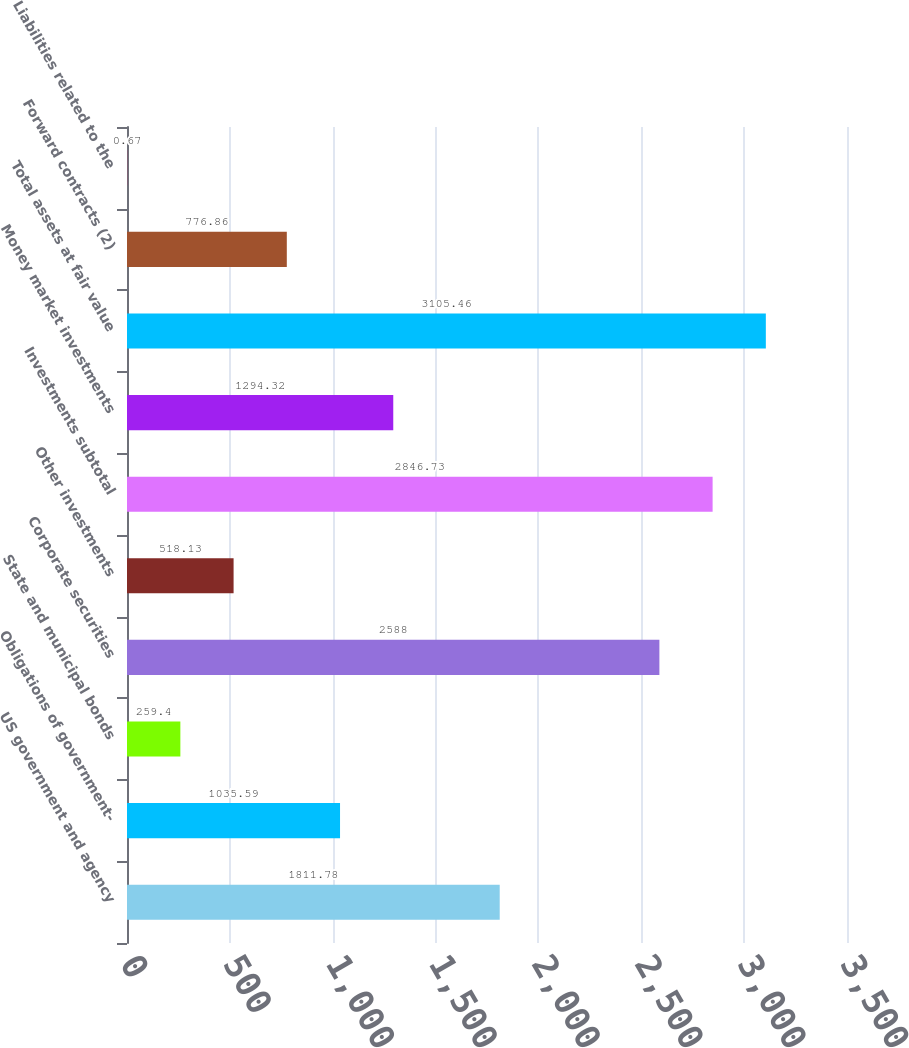<chart> <loc_0><loc_0><loc_500><loc_500><bar_chart><fcel>US government and agency<fcel>Obligations of government-<fcel>State and municipal bonds<fcel>Corporate securities<fcel>Other investments<fcel>Investments subtotal<fcel>Money market investments<fcel>Total assets at fair value<fcel>Forward contracts (2)<fcel>Liabilities related to the<nl><fcel>1811.78<fcel>1035.59<fcel>259.4<fcel>2588<fcel>518.13<fcel>2846.73<fcel>1294.32<fcel>3105.46<fcel>776.86<fcel>0.67<nl></chart> 